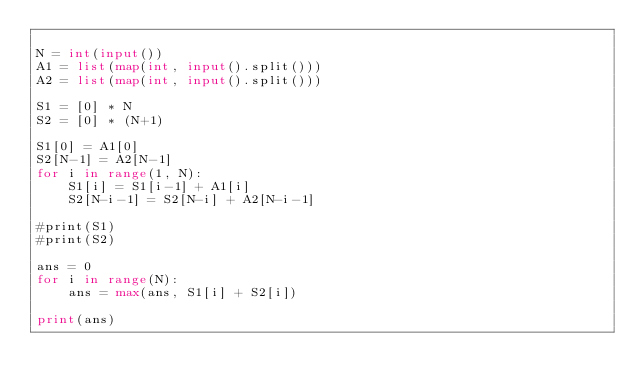Convert code to text. <code><loc_0><loc_0><loc_500><loc_500><_Python_>
N = int(input())
A1 = list(map(int, input().split()))
A2 = list(map(int, input().split()))

S1 = [0] * N
S2 = [0] * (N+1)

S1[0] = A1[0]
S2[N-1] = A2[N-1]
for i in range(1, N):
    S1[i] = S1[i-1] + A1[i]
    S2[N-i-1] = S2[N-i] + A2[N-i-1]

#print(S1)
#print(S2)

ans = 0
for i in range(N):
    ans = max(ans, S1[i] + S2[i])

print(ans)
</code> 